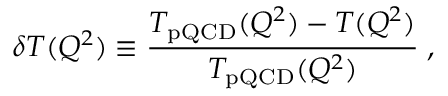<formula> <loc_0><loc_0><loc_500><loc_500>\delta T ( Q ^ { 2 } ) \equiv \frac { T _ { p Q C D } ( Q ^ { 2 } ) - T ( Q ^ { 2 } ) } { T _ { p Q C D } ( Q ^ { 2 } ) } \, ,</formula> 